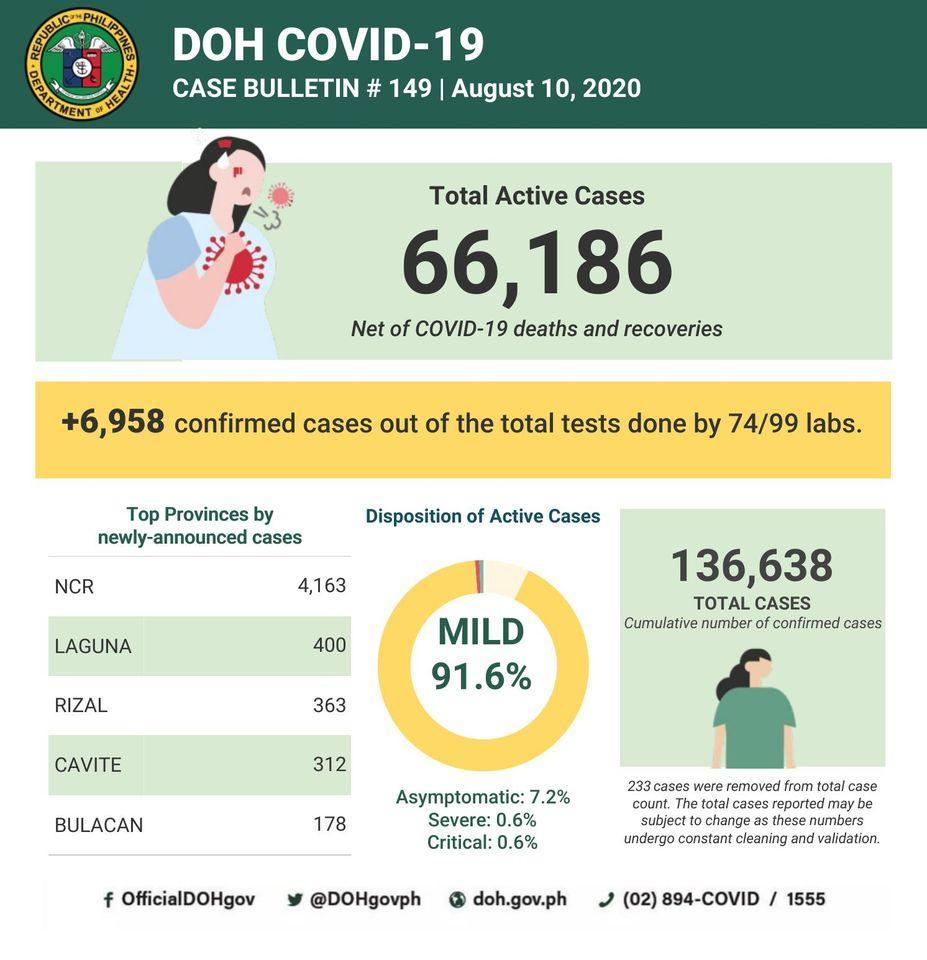What percent of cases are not mild?
Answer the question with a short phrase. 8.4% What is the Twitter handle given? @DOHgovph Which province has the least number of newly announced cases? BULACAN 